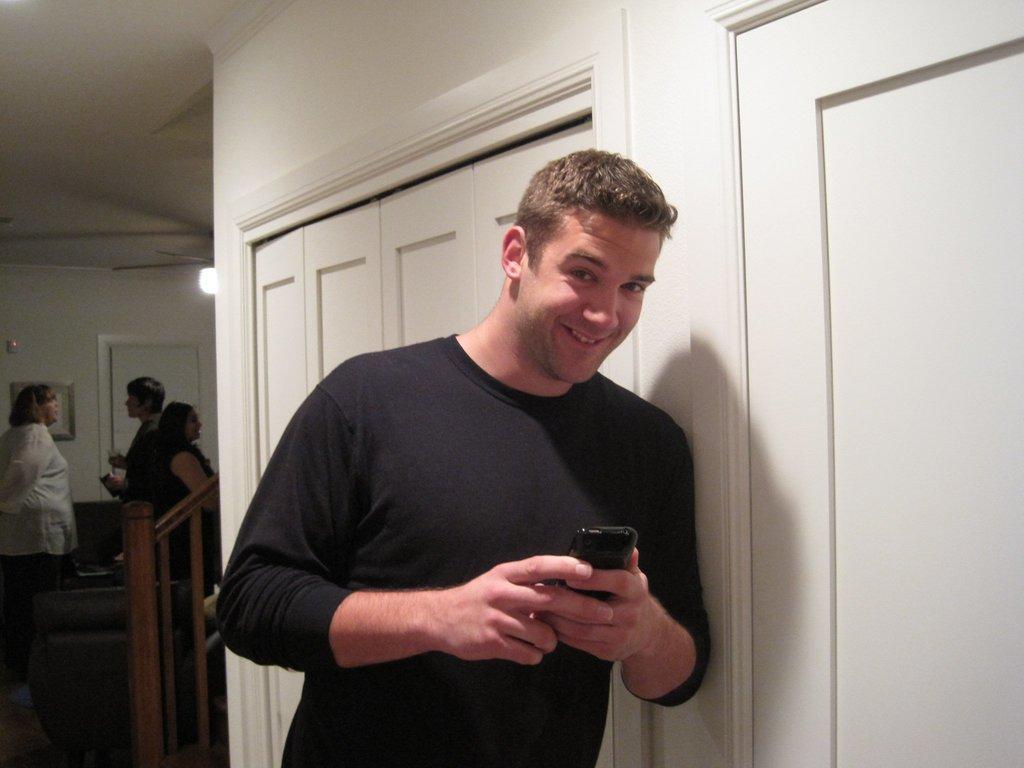In one or two sentences, can you explain what this image depicts? In the center of the image we can see a man standing and holding a mobile. On the left there are people. In the background there are doors, wall and a light. 